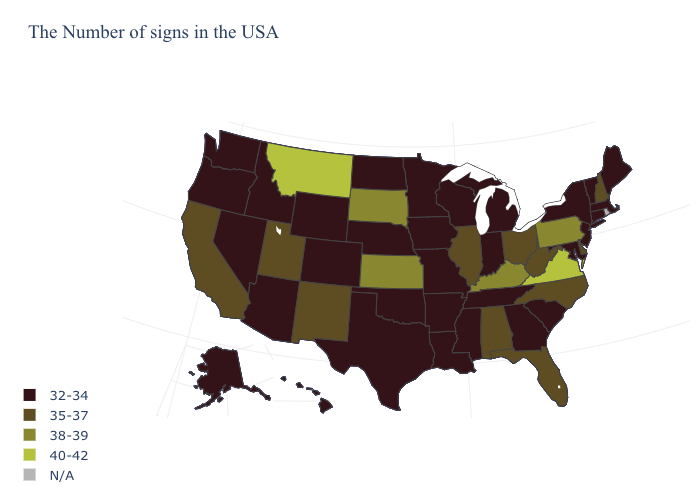Name the states that have a value in the range 35-37?
Concise answer only. New Hampshire, Delaware, North Carolina, West Virginia, Ohio, Florida, Alabama, Illinois, New Mexico, Utah, California. Does the map have missing data?
Short answer required. Yes. Does the map have missing data?
Be succinct. Yes. Among the states that border Massachusetts , does Vermont have the highest value?
Give a very brief answer. No. Name the states that have a value in the range N/A?
Short answer required. Rhode Island. Name the states that have a value in the range N/A?
Give a very brief answer. Rhode Island. What is the lowest value in the USA?
Give a very brief answer. 32-34. Does Kansas have the lowest value in the USA?
Keep it brief. No. Does the map have missing data?
Keep it brief. Yes. What is the lowest value in the USA?
Answer briefly. 32-34. Name the states that have a value in the range 35-37?
Give a very brief answer. New Hampshire, Delaware, North Carolina, West Virginia, Ohio, Florida, Alabama, Illinois, New Mexico, Utah, California. Name the states that have a value in the range N/A?
Write a very short answer. Rhode Island. Name the states that have a value in the range N/A?
Keep it brief. Rhode Island. Name the states that have a value in the range N/A?
Write a very short answer. Rhode Island. Which states have the highest value in the USA?
Answer briefly. Virginia, Montana. 